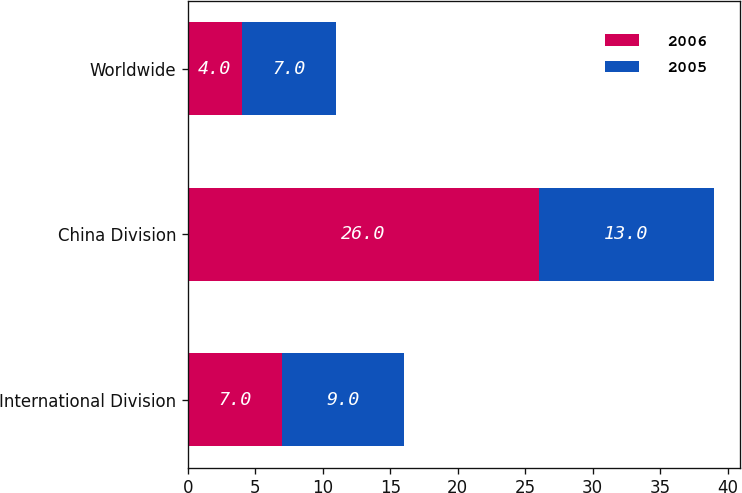Convert chart. <chart><loc_0><loc_0><loc_500><loc_500><stacked_bar_chart><ecel><fcel>International Division<fcel>China Division<fcel>Worldwide<nl><fcel>2006<fcel>7<fcel>26<fcel>4<nl><fcel>2005<fcel>9<fcel>13<fcel>7<nl></chart> 